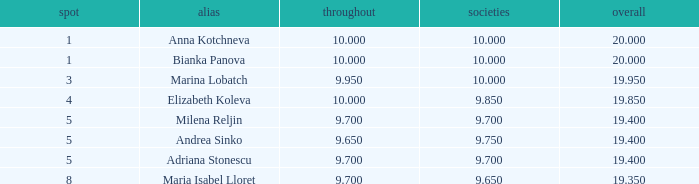How many places have bianka panova as the name, with clubs less than 10? 0.0. 